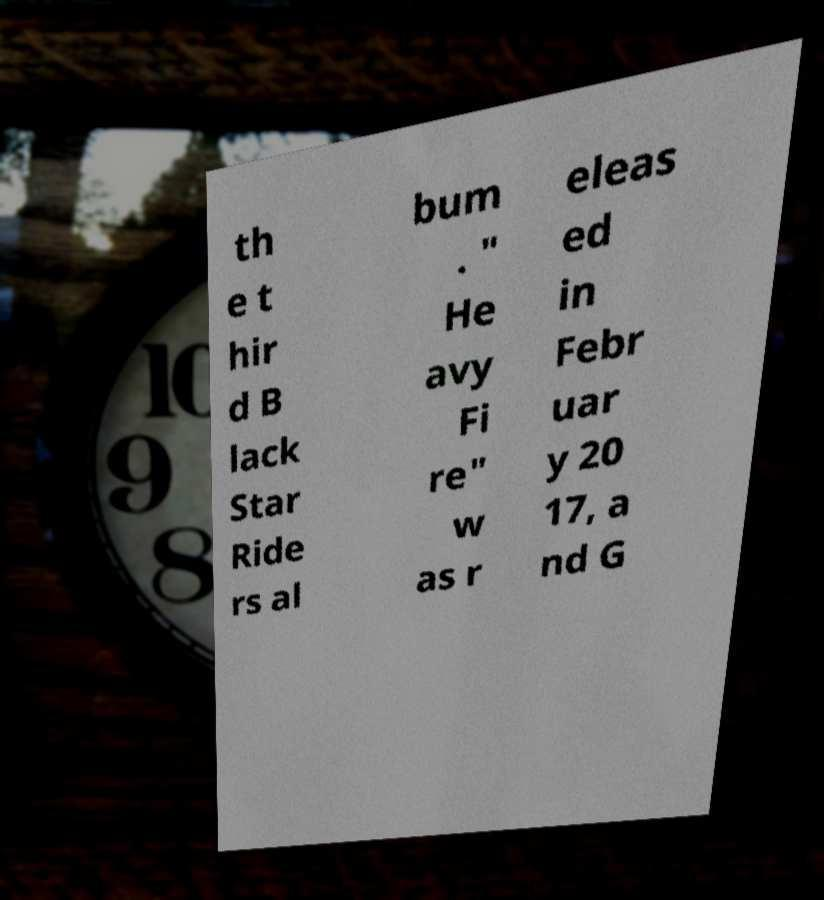There's text embedded in this image that I need extracted. Can you transcribe it verbatim? th e t hir d B lack Star Ride rs al bum . " He avy Fi re" w as r eleas ed in Febr uar y 20 17, a nd G 